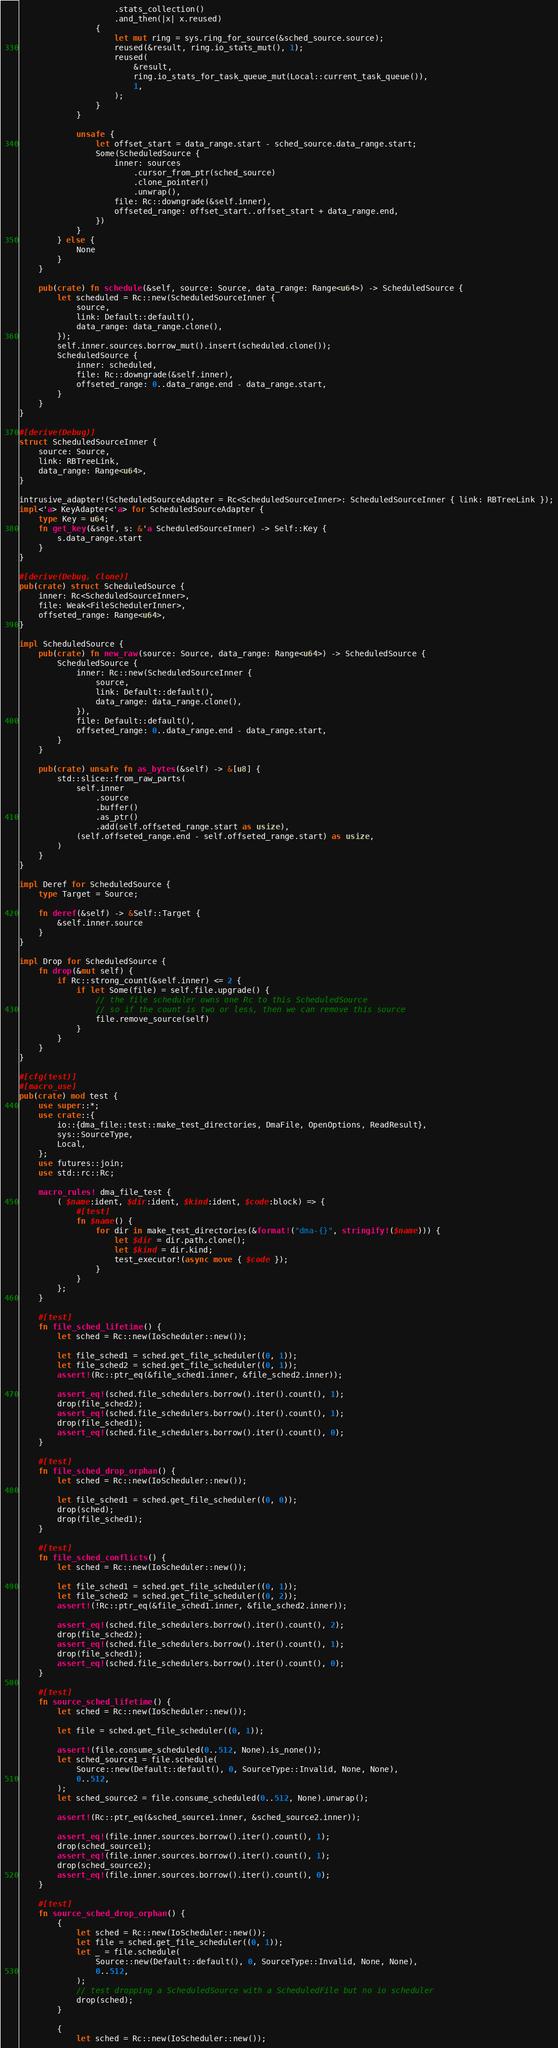Convert code to text. <code><loc_0><loc_0><loc_500><loc_500><_Rust_>                    .stats_collection()
                    .and_then(|x| x.reused)
                {
                    let mut ring = sys.ring_for_source(&sched_source.source);
                    reused(&result, ring.io_stats_mut(), 1);
                    reused(
                        &result,
                        ring.io_stats_for_task_queue_mut(Local::current_task_queue()),
                        1,
                    );
                }
            }

            unsafe {
                let offset_start = data_range.start - sched_source.data_range.start;
                Some(ScheduledSource {
                    inner: sources
                        .cursor_from_ptr(sched_source)
                        .clone_pointer()
                        .unwrap(),
                    file: Rc::downgrade(&self.inner),
                    offseted_range: offset_start..offset_start + data_range.end,
                })
            }
        } else {
            None
        }
    }

    pub(crate) fn schedule(&self, source: Source, data_range: Range<u64>) -> ScheduledSource {
        let scheduled = Rc::new(ScheduledSourceInner {
            source,
            link: Default::default(),
            data_range: data_range.clone(),
        });
        self.inner.sources.borrow_mut().insert(scheduled.clone());
        ScheduledSource {
            inner: scheduled,
            file: Rc::downgrade(&self.inner),
            offseted_range: 0..data_range.end - data_range.start,
        }
    }
}

#[derive(Debug)]
struct ScheduledSourceInner {
    source: Source,
    link: RBTreeLink,
    data_range: Range<u64>,
}

intrusive_adapter!(ScheduledSourceAdapter = Rc<ScheduledSourceInner>: ScheduledSourceInner { link: RBTreeLink });
impl<'a> KeyAdapter<'a> for ScheduledSourceAdapter {
    type Key = u64;
    fn get_key(&self, s: &'a ScheduledSourceInner) -> Self::Key {
        s.data_range.start
    }
}

#[derive(Debug, Clone)]
pub(crate) struct ScheduledSource {
    inner: Rc<ScheduledSourceInner>,
    file: Weak<FileSchedulerInner>,
    offseted_range: Range<u64>,
}

impl ScheduledSource {
    pub(crate) fn new_raw(source: Source, data_range: Range<u64>) -> ScheduledSource {
        ScheduledSource {
            inner: Rc::new(ScheduledSourceInner {
                source,
                link: Default::default(),
                data_range: data_range.clone(),
            }),
            file: Default::default(),
            offseted_range: 0..data_range.end - data_range.start,
        }
    }

    pub(crate) unsafe fn as_bytes(&self) -> &[u8] {
        std::slice::from_raw_parts(
            self.inner
                .source
                .buffer()
                .as_ptr()
                .add(self.offseted_range.start as usize),
            (self.offseted_range.end - self.offseted_range.start) as usize,
        )
    }
}

impl Deref for ScheduledSource {
    type Target = Source;

    fn deref(&self) -> &Self::Target {
        &self.inner.source
    }
}

impl Drop for ScheduledSource {
    fn drop(&mut self) {
        if Rc::strong_count(&self.inner) <= 2 {
            if let Some(file) = self.file.upgrade() {
                // the file scheduler owns one Rc to this ScheduledSource
                // so if the count is two or less, then we can remove this source
                file.remove_source(self)
            }
        }
    }
}

#[cfg(test)]
#[macro_use]
pub(crate) mod test {
    use super::*;
    use crate::{
        io::{dma_file::test::make_test_directories, DmaFile, OpenOptions, ReadResult},
        sys::SourceType,
        Local,
    };
    use futures::join;
    use std::rc::Rc;

    macro_rules! dma_file_test {
        ( $name:ident, $dir:ident, $kind:ident, $code:block) => {
            #[test]
            fn $name() {
                for dir in make_test_directories(&format!("dma-{}", stringify!($name))) {
                    let $dir = dir.path.clone();
                    let $kind = dir.kind;
                    test_executor!(async move { $code });
                }
            }
        };
    }

    #[test]
    fn file_sched_lifetime() {
        let sched = Rc::new(IoScheduler::new());

        let file_sched1 = sched.get_file_scheduler((0, 1));
        let file_sched2 = sched.get_file_scheduler((0, 1));
        assert!(Rc::ptr_eq(&file_sched1.inner, &file_sched2.inner));

        assert_eq!(sched.file_schedulers.borrow().iter().count(), 1);
        drop(file_sched2);
        assert_eq!(sched.file_schedulers.borrow().iter().count(), 1);
        drop(file_sched1);
        assert_eq!(sched.file_schedulers.borrow().iter().count(), 0);
    }

    #[test]
    fn file_sched_drop_orphan() {
        let sched = Rc::new(IoScheduler::new());

        let file_sched1 = sched.get_file_scheduler((0, 0));
        drop(sched);
        drop(file_sched1);
    }

    #[test]
    fn file_sched_conflicts() {
        let sched = Rc::new(IoScheduler::new());

        let file_sched1 = sched.get_file_scheduler((0, 1));
        let file_sched2 = sched.get_file_scheduler((0, 2));
        assert!(!Rc::ptr_eq(&file_sched1.inner, &file_sched2.inner));

        assert_eq!(sched.file_schedulers.borrow().iter().count(), 2);
        drop(file_sched2);
        assert_eq!(sched.file_schedulers.borrow().iter().count(), 1);
        drop(file_sched1);
        assert_eq!(sched.file_schedulers.borrow().iter().count(), 0);
    }

    #[test]
    fn source_sched_lifetime() {
        let sched = Rc::new(IoScheduler::new());

        let file = sched.get_file_scheduler((0, 1));

        assert!(file.consume_scheduled(0..512, None).is_none());
        let sched_source1 = file.schedule(
            Source::new(Default::default(), 0, SourceType::Invalid, None, None),
            0..512,
        );
        let sched_source2 = file.consume_scheduled(0..512, None).unwrap();

        assert!(Rc::ptr_eq(&sched_source1.inner, &sched_source2.inner));

        assert_eq!(file.inner.sources.borrow().iter().count(), 1);
        drop(sched_source1);
        assert_eq!(file.inner.sources.borrow().iter().count(), 1);
        drop(sched_source2);
        assert_eq!(file.inner.sources.borrow().iter().count(), 0);
    }

    #[test]
    fn source_sched_drop_orphan() {
        {
            let sched = Rc::new(IoScheduler::new());
            let file = sched.get_file_scheduler((0, 1));
            let _ = file.schedule(
                Source::new(Default::default(), 0, SourceType::Invalid, None, None),
                0..512,
            );
            // test dropping a ScheduledSource with a ScheduledFile but no io scheduler
            drop(sched);
        }

        {
            let sched = Rc::new(IoScheduler::new());</code> 